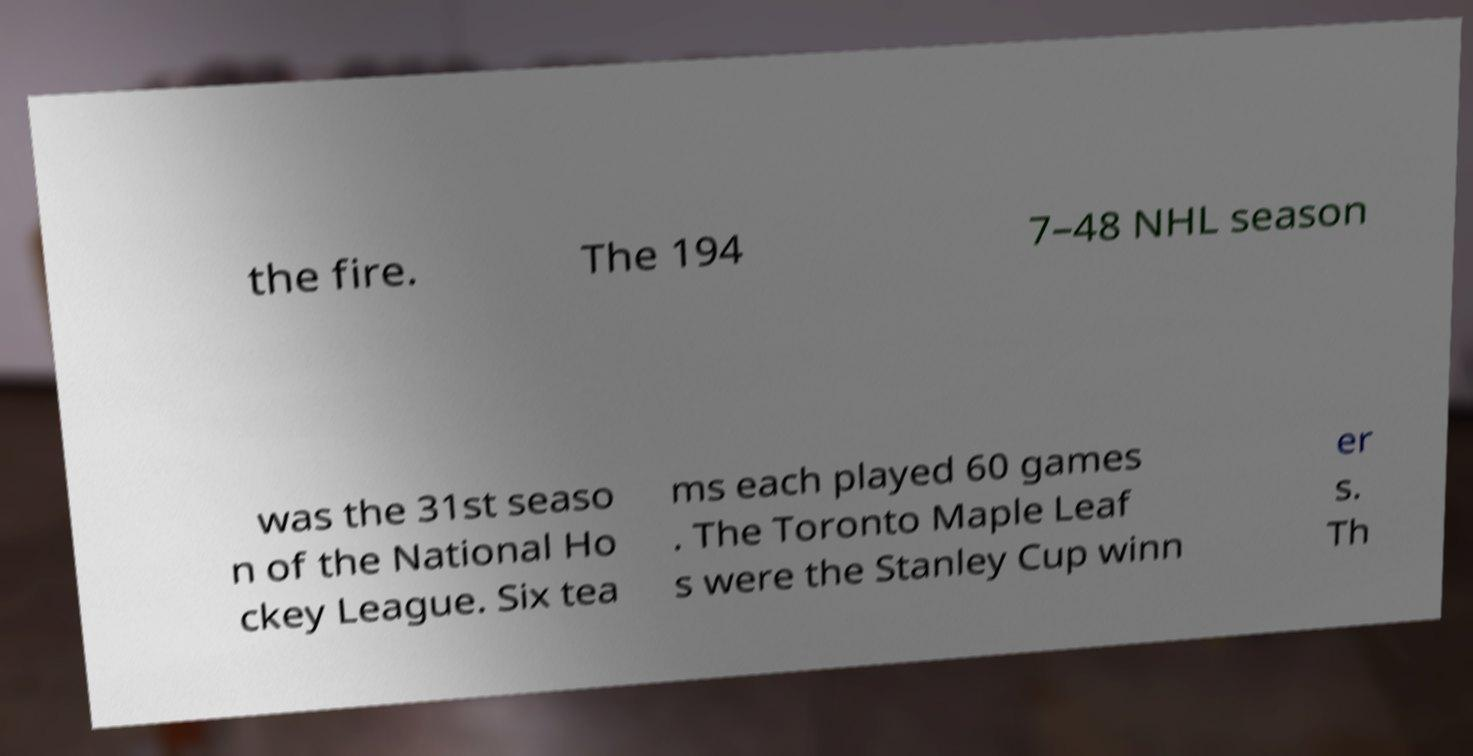Could you assist in decoding the text presented in this image and type it out clearly? the fire. The 194 7–48 NHL season was the 31st seaso n of the National Ho ckey League. Six tea ms each played 60 games . The Toronto Maple Leaf s were the Stanley Cup winn er s. Th 